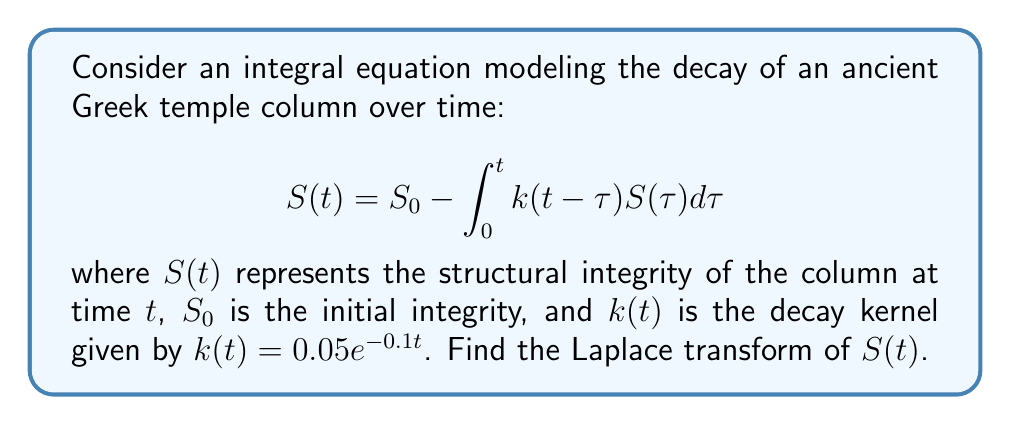Could you help me with this problem? To solve this problem, we'll follow these steps:

1) First, let's take the Laplace transform of both sides of the equation:
   $$\mathcal{L}\{S(t)\} = \mathcal{L}\{S_0\} - \mathcal{L}\{\int_0^t k(t-\tau)S(\tau)d\tau\}$$

2) The Laplace transform of a constant $S_0$ is $S_0/s$. Let's denote $\mathcal{L}\{S(t)\}$ as $\bar{S}(s)$:
   $$\bar{S}(s) = \frac{S_0}{s} - \mathcal{L}\{\int_0^t k(t-\tau)S(\tau)d\tau\}$$

3) The integral in the equation is a convolution. The Laplace transform of a convolution is the product of the Laplace transforms:
   $$\bar{S}(s) = \frac{S_0}{s} - \mathcal{L}\{k(t)\} \cdot \bar{S}(s)$$

4) Now we need to find $\mathcal{L}\{k(t)\}$:
   $$\mathcal{L}\{k(t)\} = \mathcal{L}\{0.05e^{-0.1t}\} = \frac{0.05}{s+0.1}$$

5) Substituting this back into our equation:
   $$\bar{S}(s) = \frac{S_0}{s} - \frac{0.05}{s+0.1} \cdot \bar{S}(s)$$

6) Now we can solve for $\bar{S}(s)$:
   $$\bar{S}(s) + \frac{0.05}{s+0.1} \cdot \bar{S}(s) = \frac{S_0}{s}$$
   $$\bar{S}(s) \cdot (1 + \frac{0.05}{s+0.1}) = \frac{S_0}{s}$$
   $$\bar{S}(s) \cdot (\frac{s+0.1 + 0.05}{s+0.1}) = \frac{S_0}{s}$$

7) Finally, we can express $\bar{S}(s)$:
   $$\bar{S}(s) = \frac{S_0}{s} \cdot \frac{s+0.1}{s+0.15}$$
Answer: $\bar{S}(s) = \frac{S_0(s+0.1)}{s(s+0.15)}$ 